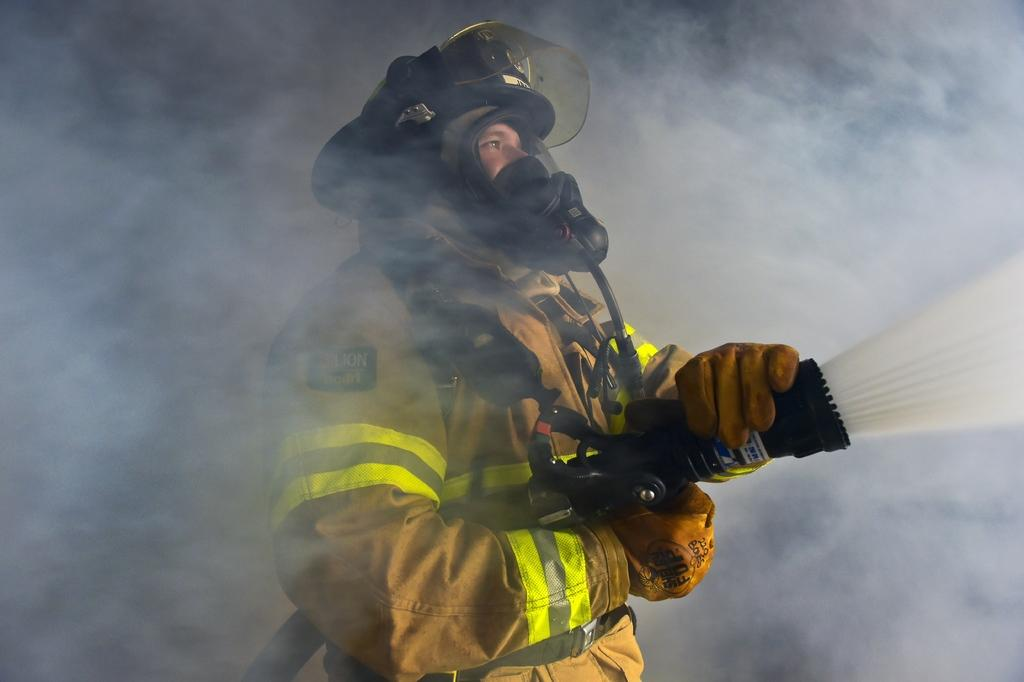What is the person in the image wearing on their face? The person is wearing a mask in the image. What other protective gear is the person wearing? The person is also wearing a helmet and gloves. What is the person holding in the image? The person is holding a pipe in the image. What is the person doing with the pipe? The person is spraying water with the pipe. What can be seen as a result of the person spraying water? There is smoke visible in the image. What type of pan is the person using to cook in the image? There is no pan present in the image; the person is holding a pipe and spraying water. Can you point out where the dinosaurs are hiding in the image? There are no dinosaurs present in the image. 